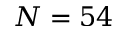<formula> <loc_0><loc_0><loc_500><loc_500>N = 5 4</formula> 